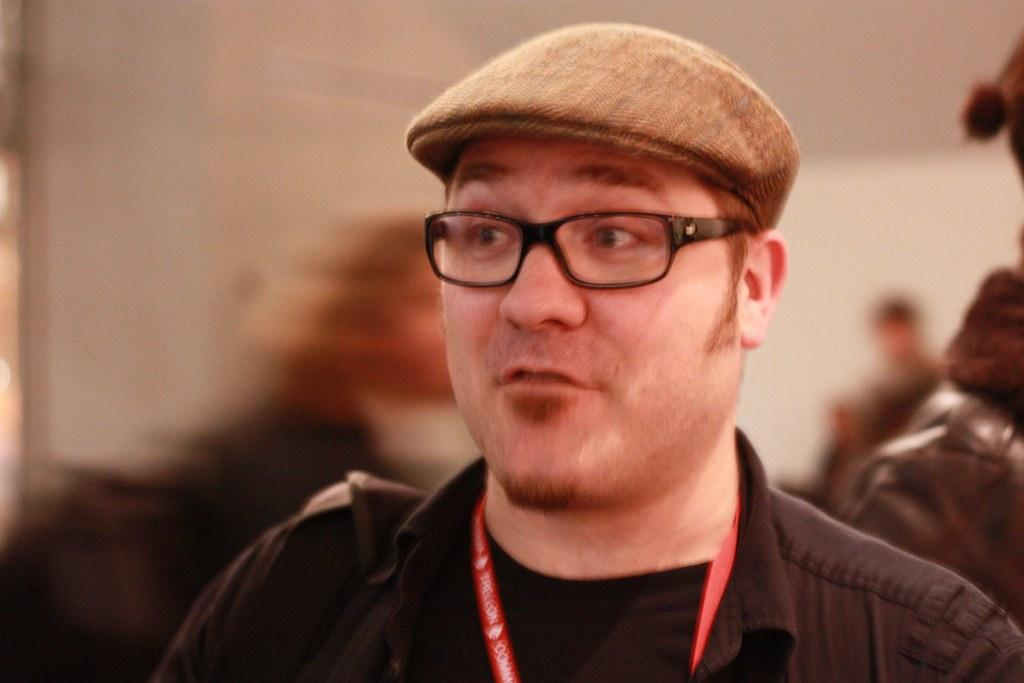Who is the main subject in the image? There is a man in the image. What is the man about to do? The man is about to speak. What can be seen on the man's clothing? The man is wearing an ID card. What accessories is the man wearing? The man is wearing spectacles and a brown hat. How is the background of the image depicted? The background of the man is blurred. What type of bucket is the man holding in the image? There is no bucket present in the image. What idea does the man have in the image? The image does not convey any specific ideas or thoughts of the man. 